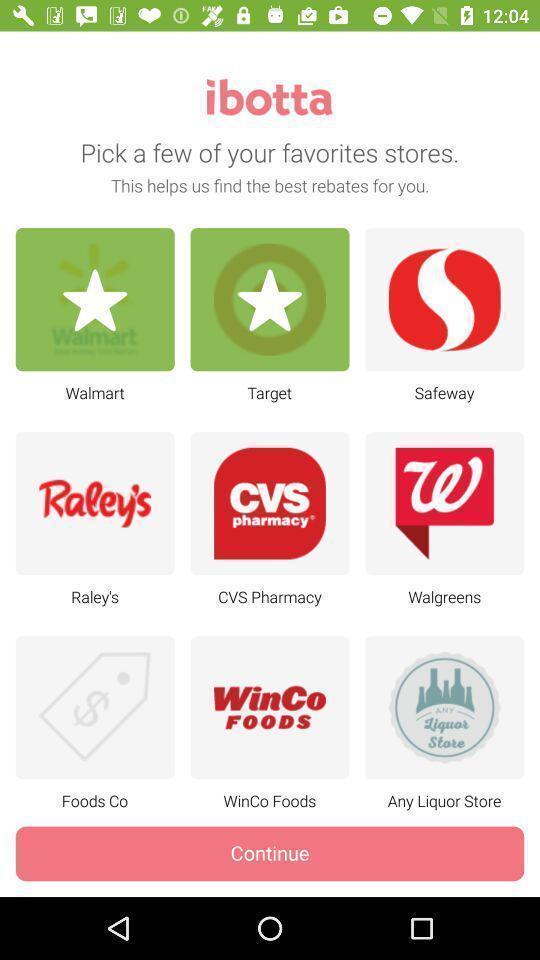Give me a narrative description of this picture. Screen showing pick few of your favorites stores. 